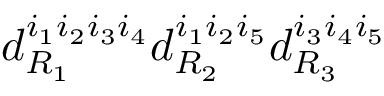Convert formula to latex. <formula><loc_0><loc_0><loc_500><loc_500>d _ { R _ { 1 } } ^ { i _ { 1 } i _ { 2 } i _ { 3 } i _ { 4 } } d _ { R _ { 2 } } ^ { i _ { 1 } i _ { 2 } i _ { 5 } } d _ { R _ { 3 } } ^ { i _ { 3 } i _ { 4 } i _ { 5 } }</formula> 